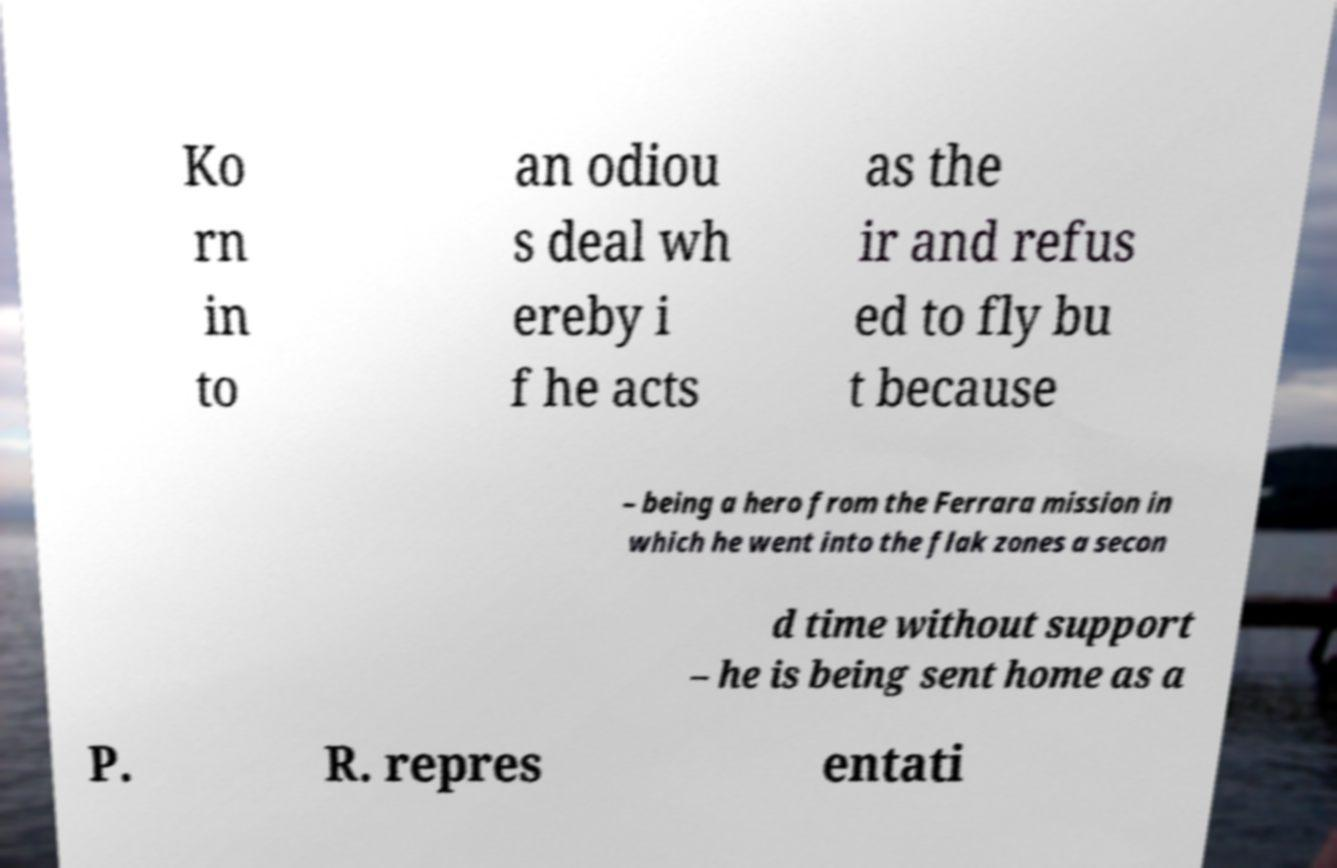I need the written content from this picture converted into text. Can you do that? Ko rn in to an odiou s deal wh ereby i f he acts as the ir and refus ed to fly bu t because – being a hero from the Ferrara mission in which he went into the flak zones a secon d time without support – he is being sent home as a P. R. repres entati 